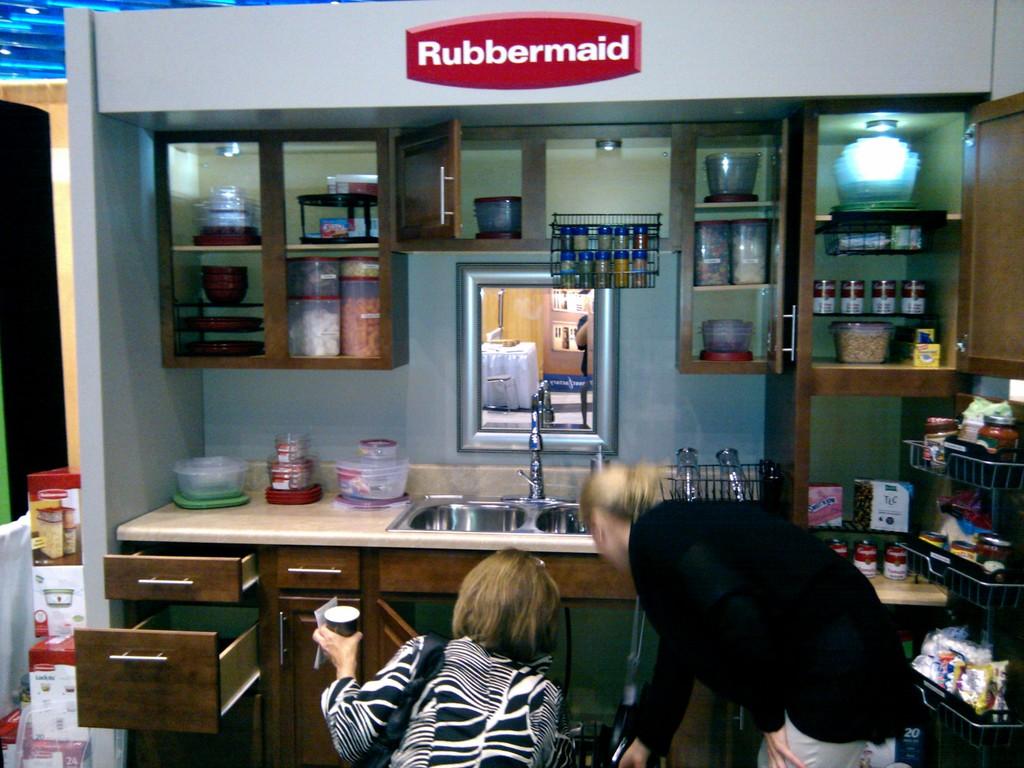What brand is this display for?
Ensure brevity in your answer.  Rubbermaid. 